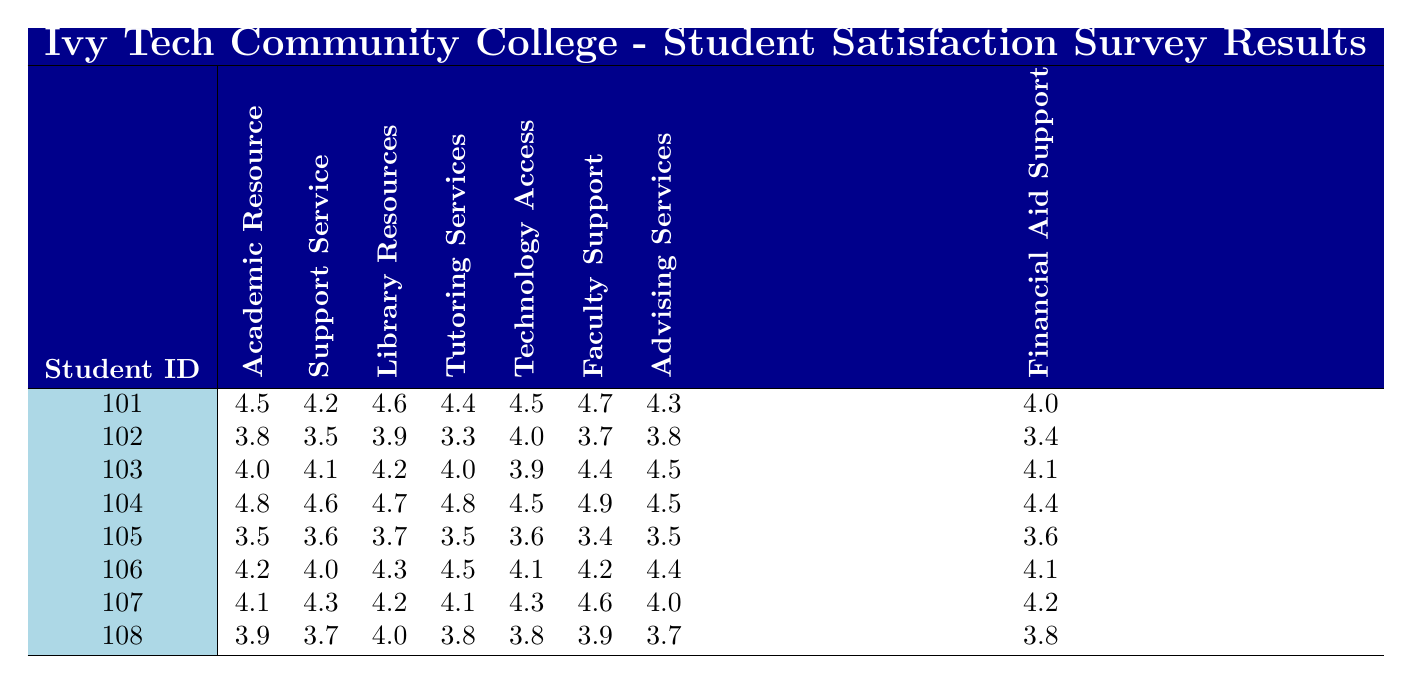What is the highest satisfaction score for Faculty Support? By examining the Faculty Support column, the highest score is found as 4.9, which corresponds to Student ID 104.
Answer: 4.9 What is the lowest satisfaction score in the Support Service category? Looking at the Support Service column, the lowest score is 3.5 from Student ID 102.
Answer: 3.5 How many students rated Technology Access above 4.0? Checking the Technology Access ratings, the students with scores above 4.0 are Student IDs 101, 102, 104, 106, and 107, totaling 5 students.
Answer: 5 What is the average satisfaction score for Library Resources? Sum the Library Resources scores (4.6 + 3.9 + 4.2 + 4.7 + 3.7 + 4.3 + 4.2 + 4.0) = 33.2. There are 8 students, thus the average is 33.2 / 8 = 4.15.
Answer: 4.15 Is there a student who rated both Academic Resource Satisfaction and Support Service Satisfaction as 4.0 or higher? Reviewing the scores, Students 101, 103, 104, 106, and 107 all rated both categories 4.0 or higher.
Answer: Yes Which student has the highest combined satisfaction score for Academic Resource and Support Service categories? Add the scores for each student: Student 101 (4.5 + 4.2 = 8.7), 102 (3.8 + 3.5 = 7.3), 103 (4.0 + 4.1 = 8.1), 104 (4.8 + 4.6 = 9.4), 105 (3.5 + 3.6 = 7.1), 106 (4.2 + 4.0 = 8.2), 107 (4.1 + 4.3 = 8.4), and 108 (3.9 + 3.7 = 7.6). The highest score is 9.4 from Student ID 104.
Answer: 104 What is the difference in satisfaction scores between the best and worst ratings for Tutoring Services? The highest is 4.8 from Student ID 104 and the lowest is 3.3 from Student ID 102. The difference is 4.8 - 3.3 = 1.5.
Answer: 1.5 Which support service received the most consistent ratings (lowest range) among students? To find this, determine the maximum and minimum scores for each support service. The smallest range is for Faculty Support (4.9 - 3.4 = 1.5).
Answer: Faculty Support How many students rated Financial Aid Support below a score of 4.0? Identify the scores under 4.0 in Financial Aid Support: 4.0 (Student 101), 3.4 (Student 102), 4.1 (Student 103), 4.4 (Student 104), 3.6 (Student 105), 4.1 (Student 106), 4.2 (Student 107), 3.8 (Student 108). Only Student IDs 102 and 105 rated below 4.0, totaling 2 students.
Answer: 2 Which resources had the highest individual satisfaction from all students surveyed? By reviewing the highest satisfaction scores for each category, Faculty Support has the highest individual score at 4.9.
Answer: Faculty Support (4.9) 